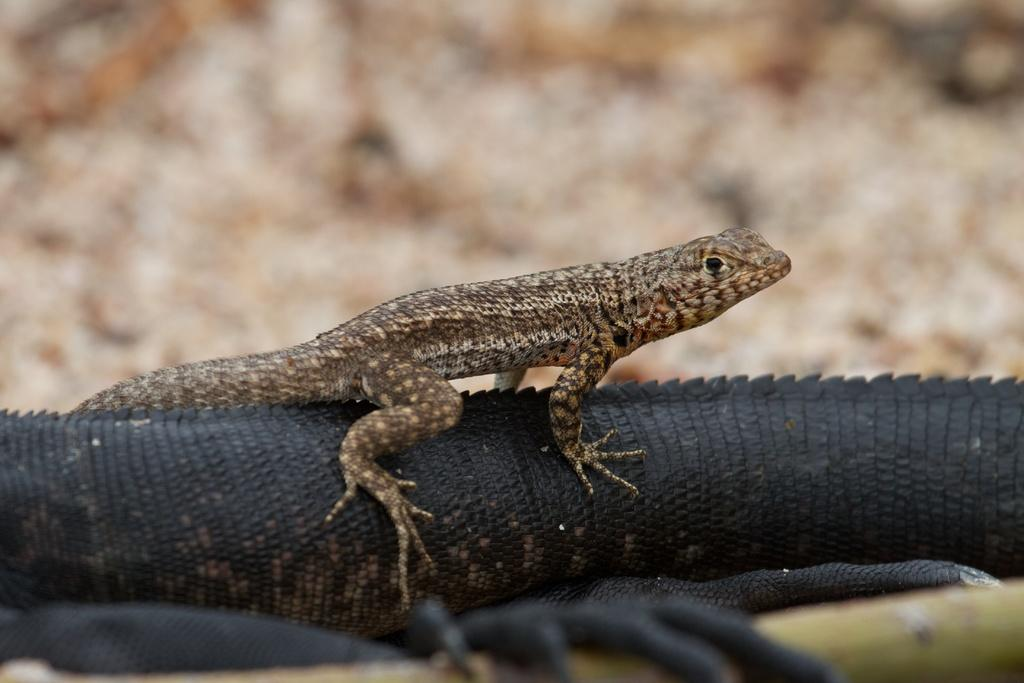What animals are located in the center of the image? There are crocodiles in the center of the image. What advice can be seen written on the seashore in the image? There is no advice or seashore present in the image; it features crocodiles in the center. 